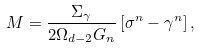<formula> <loc_0><loc_0><loc_500><loc_500>M = \frac { \Sigma _ { \gamma } } { 2 \Omega _ { d - 2 } G _ { n } } \left [ \sigma ^ { n } - \gamma ^ { n } \right ] ,</formula> 